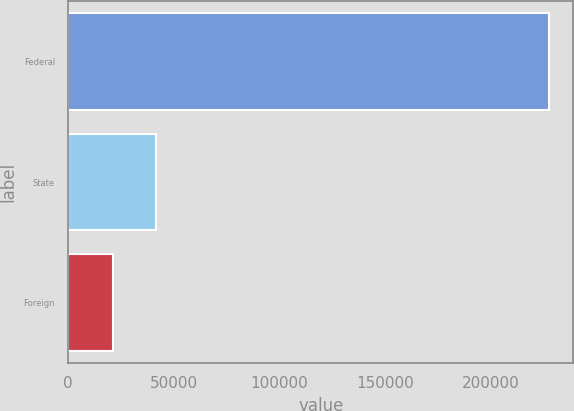<chart> <loc_0><loc_0><loc_500><loc_500><bar_chart><fcel>Federal<fcel>State<fcel>Foreign<nl><fcel>227488<fcel>41661.4<fcel>21014<nl></chart> 